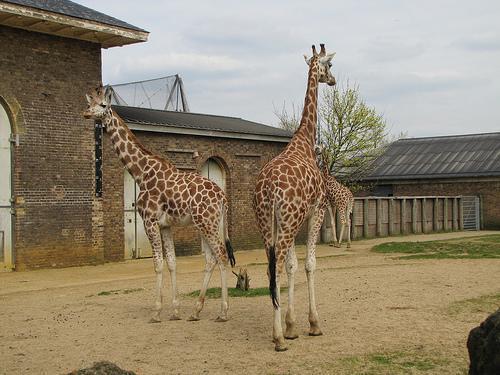How many giraffes are facing the camera?
Give a very brief answer. 1. 